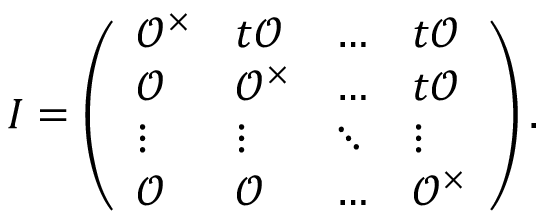Convert formula to latex. <formula><loc_0><loc_0><loc_500><loc_500>I = \left ( \begin{array} { l l l l } { \mathcal { O } ^ { \times } } & { t \mathcal { O } } & { \dots } & { t \mathcal { O } } \\ { \mathcal { O } } & { \mathcal { O } ^ { \times } } & { \dots } & { t \mathcal { O } } \\ { \vdots } & { \vdots } & { \ddots } & { \vdots } \\ { \mathcal { O } } & { \mathcal { O } } & { \dots } & { \mathcal { O } ^ { \times } } \end{array} \right ) .</formula> 